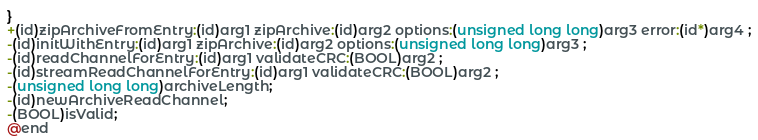Convert code to text. <code><loc_0><loc_0><loc_500><loc_500><_C_>}
+(id)zipArchiveFromEntry:(id)arg1 zipArchive:(id)arg2 options:(unsigned long long)arg3 error:(id*)arg4 ;
-(id)initWithEntry:(id)arg1 zipArchive:(id)arg2 options:(unsigned long long)arg3 ;
-(id)readChannelForEntry:(id)arg1 validateCRC:(BOOL)arg2 ;
-(id)streamReadChannelForEntry:(id)arg1 validateCRC:(BOOL)arg2 ;
-(unsigned long long)archiveLength;
-(id)newArchiveReadChannel;
-(BOOL)isValid;
@end

</code> 